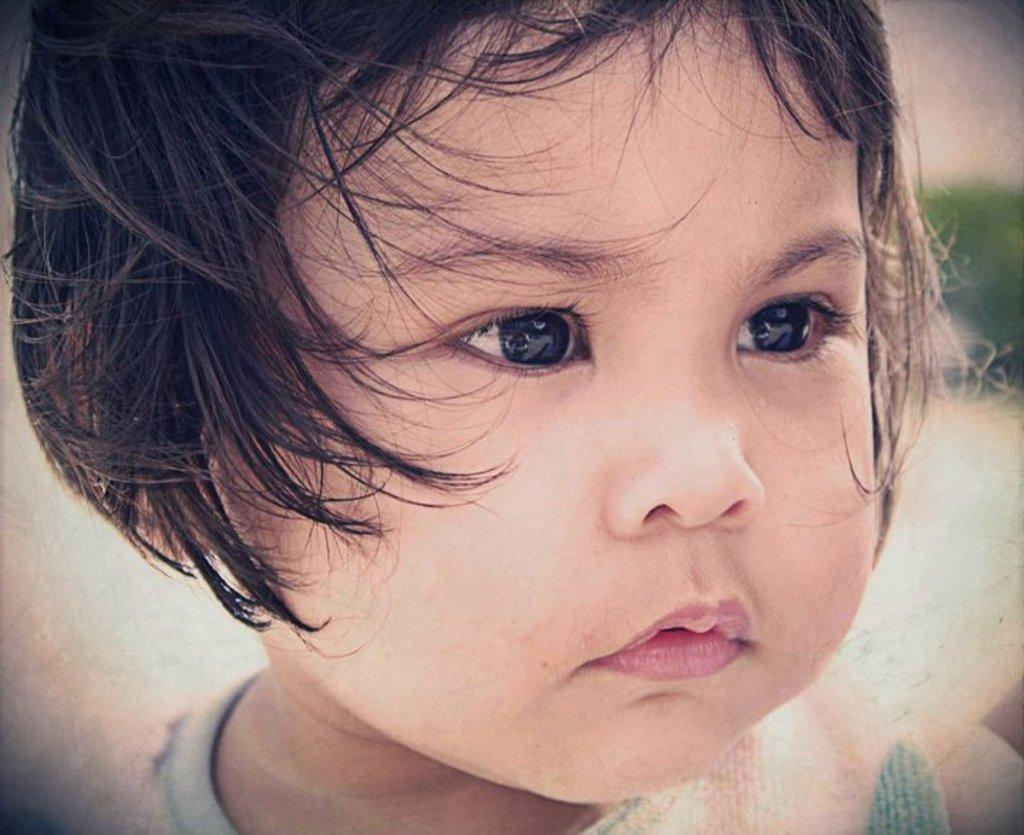What is the main subject of the image? There is a baby's face in the image. What can be seen on the right side of the image? There is a green-colored object on the right side of the image. How would you describe the overall clarity of the image? The image is blurry in the background. Reasoning: Let's think step by step by step in order to produce the conversation. We start by identifying the main subject of the image, which is the baby's face. Then, we describe the secondary object in the image, which is the green-colored object on the right side. Finally, we address the overall quality of the image by mentioning that it is blurry in the background. Absurd Question/Answer: Can you tell me how many quince are present in the image? There are no quince present in the image. What type of scarecrow can be seen in the image? There is no scarecrow present in the image. Can you tell me how many hydrants are present in the image? There are no hydrants present in the image. What type of scarecrow can be seen in the image? There is no scarecrow present in the image. 